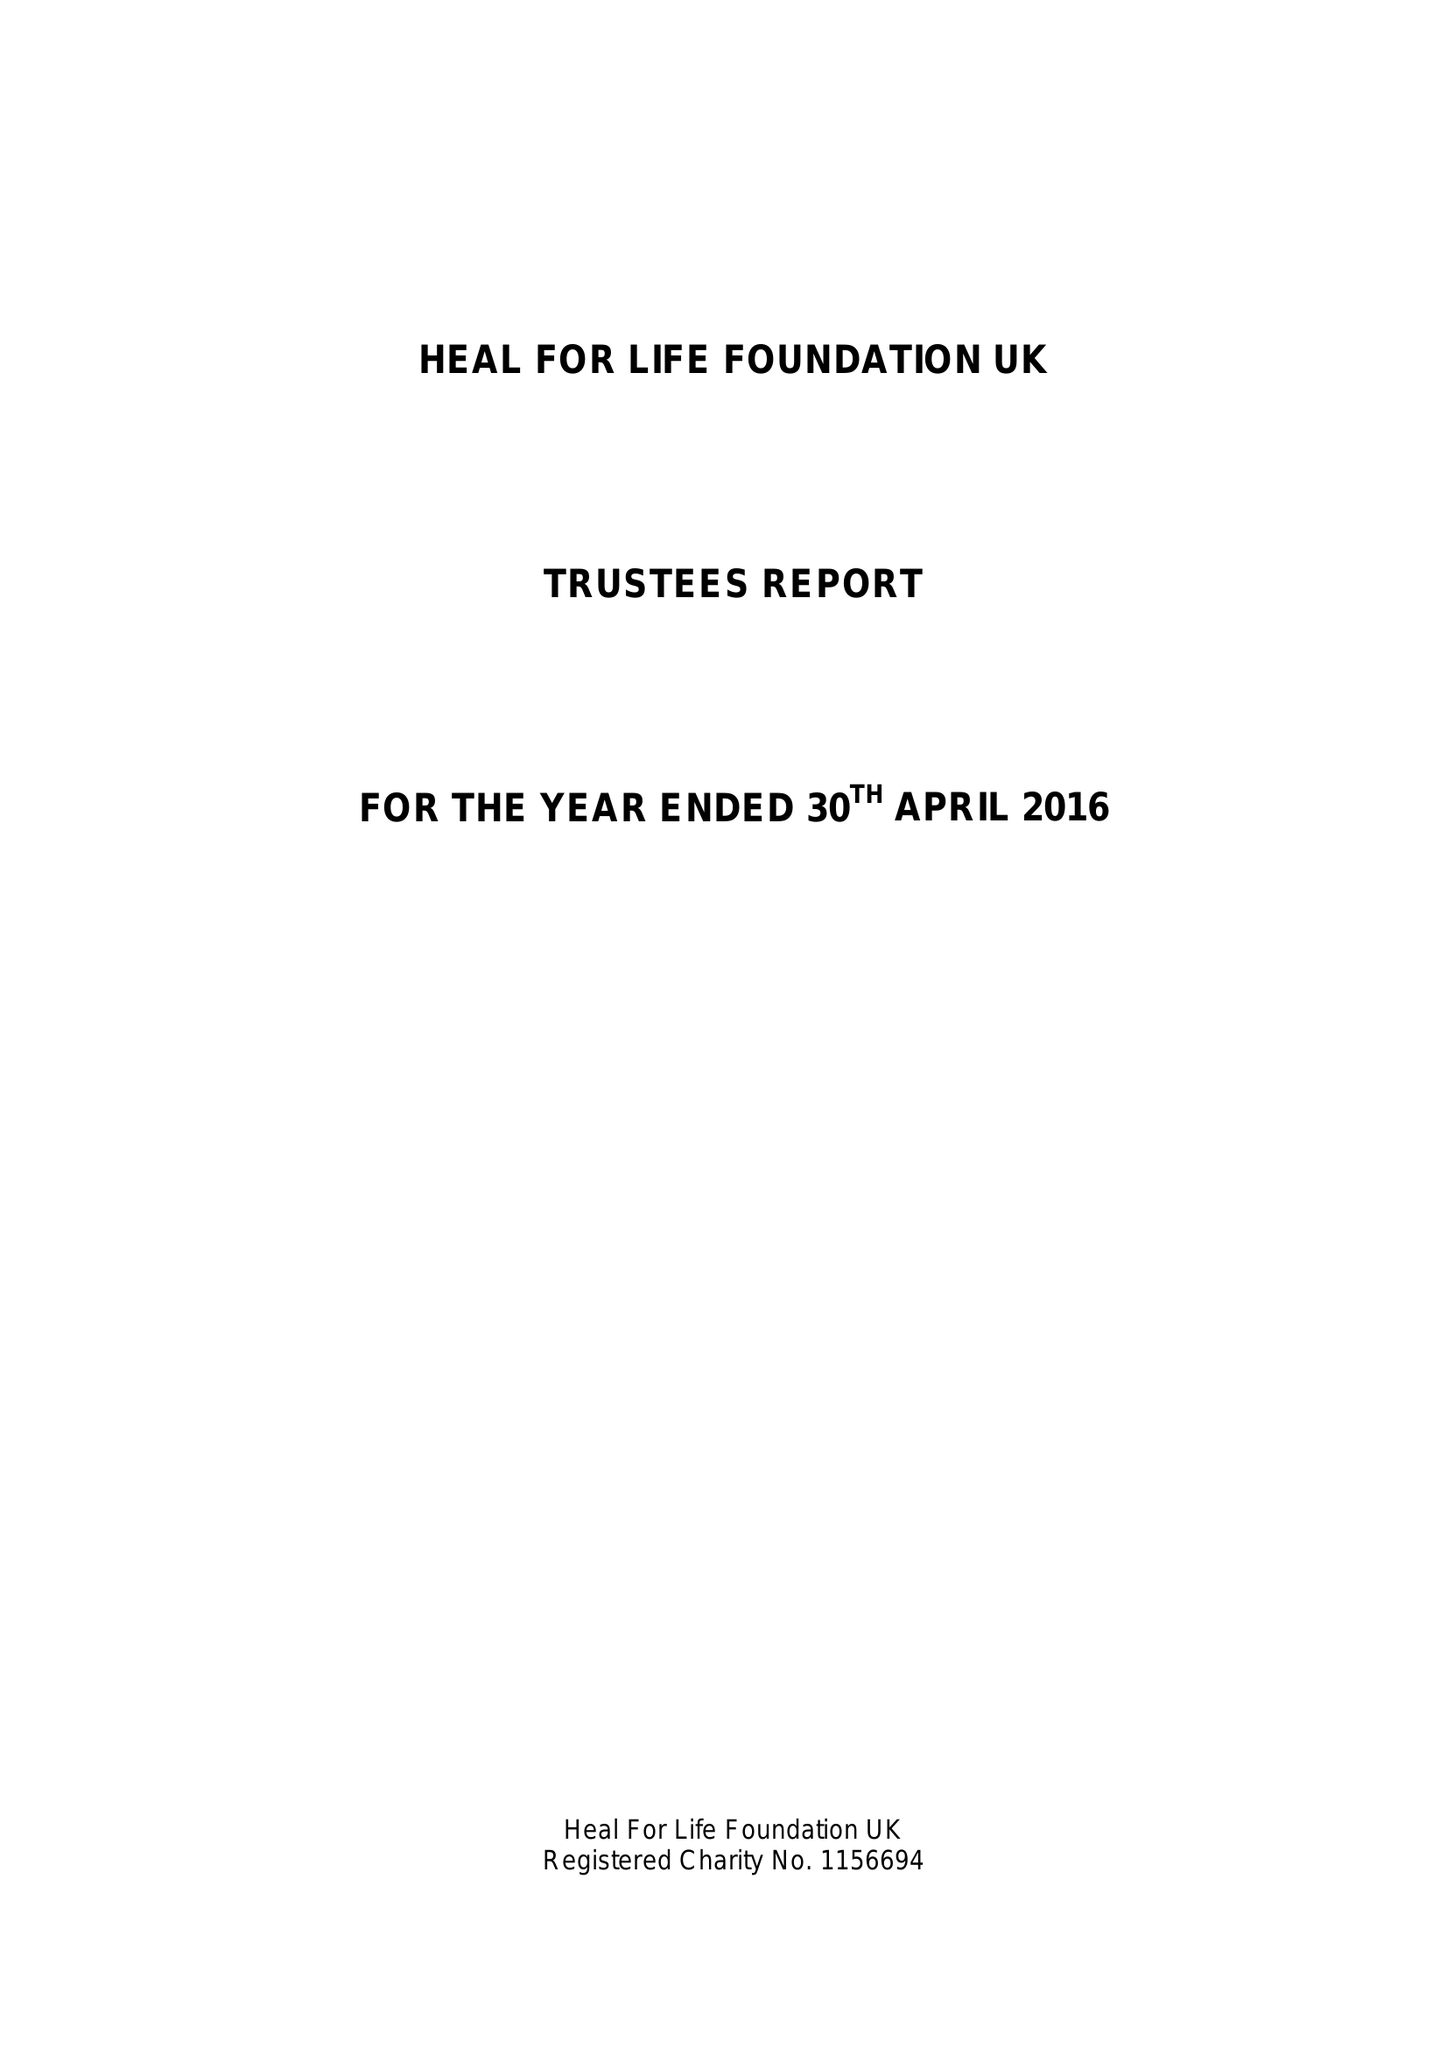What is the value for the address__street_line?
Answer the question using a single word or phrase. 24 CHURCH STREET 